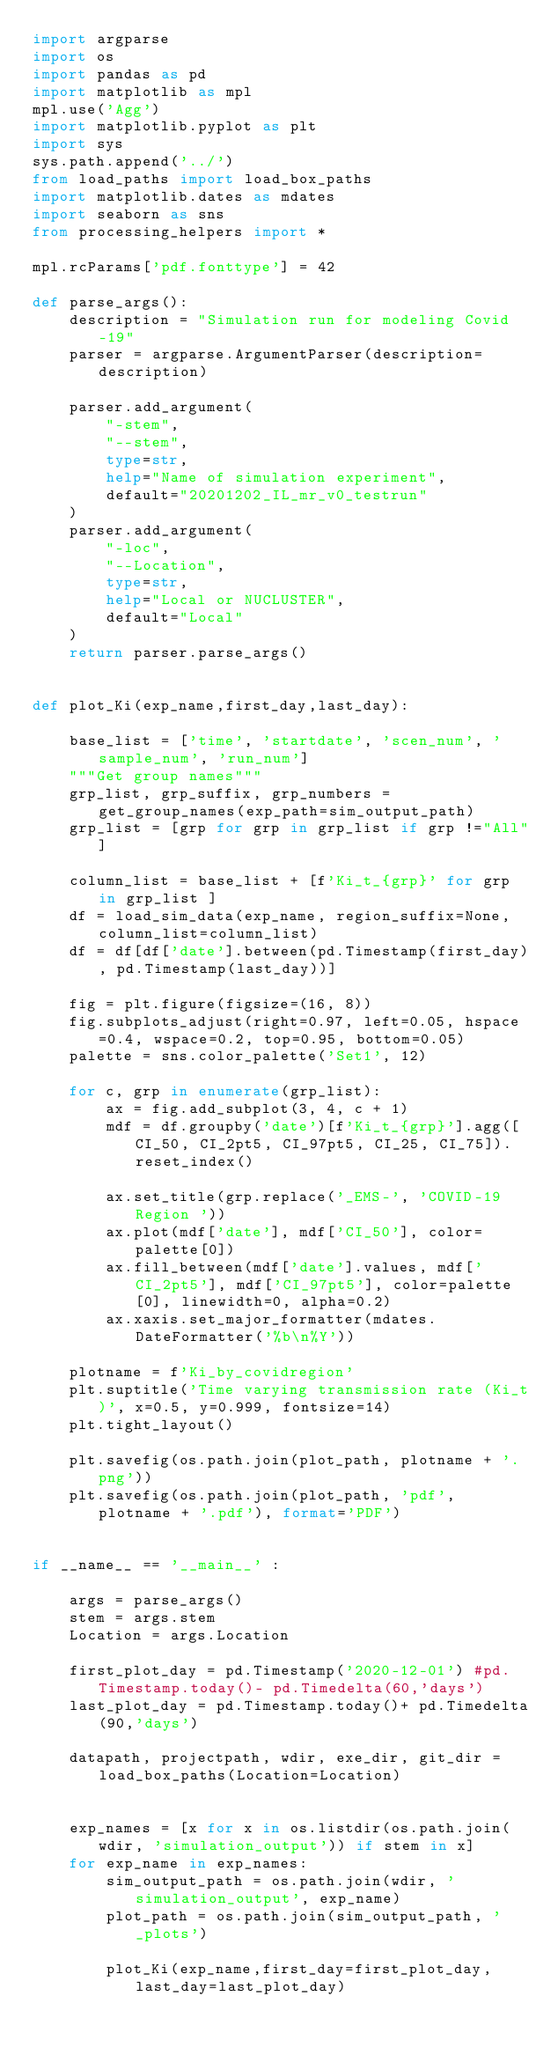Convert code to text. <code><loc_0><loc_0><loc_500><loc_500><_Python_>import argparse
import os
import pandas as pd
import matplotlib as mpl
mpl.use('Agg')
import matplotlib.pyplot as plt
import sys
sys.path.append('../')
from load_paths import load_box_paths
import matplotlib.dates as mdates
import seaborn as sns
from processing_helpers import *

mpl.rcParams['pdf.fonttype'] = 42

def parse_args():
    description = "Simulation run for modeling Covid-19"
    parser = argparse.ArgumentParser(description=description)

    parser.add_argument(
        "-stem",
        "--stem",
        type=str,
        help="Name of simulation experiment",
        default="20201202_IL_mr_v0_testrun"
    )
    parser.add_argument(
        "-loc",
        "--Location",
        type=str,
        help="Local or NUCLUSTER",
        default="Local"
    )
    return parser.parse_args()


def plot_Ki(exp_name,first_day,last_day):

    base_list = ['time', 'startdate', 'scen_num', 'sample_num', 'run_num']
    """Get group names"""
    grp_list, grp_suffix, grp_numbers = get_group_names(exp_path=sim_output_path)
    grp_list = [grp for grp in grp_list if grp !="All"]

    column_list = base_list + [f'Ki_t_{grp}' for grp in grp_list ]
    df = load_sim_data(exp_name, region_suffix=None, column_list=column_list)
    df = df[df['date'].between(pd.Timestamp(first_day), pd.Timestamp(last_day))]

    fig = plt.figure(figsize=(16, 8))
    fig.subplots_adjust(right=0.97, left=0.05, hspace=0.4, wspace=0.2, top=0.95, bottom=0.05)
    palette = sns.color_palette('Set1', 12)

    for c, grp in enumerate(grp_list):
        ax = fig.add_subplot(3, 4, c + 1)
        mdf = df.groupby('date')[f'Ki_t_{grp}'].agg([CI_50, CI_2pt5, CI_97pt5, CI_25, CI_75]).reset_index()

        ax.set_title(grp.replace('_EMS-', 'COVID-19 Region '))
        ax.plot(mdf['date'], mdf['CI_50'], color=palette[0])
        ax.fill_between(mdf['date'].values, mdf['CI_2pt5'], mdf['CI_97pt5'], color=palette[0], linewidth=0, alpha=0.2)
        ax.xaxis.set_major_formatter(mdates.DateFormatter('%b\n%Y'))

    plotname = f'Ki_by_covidregion'
    plt.suptitle('Time varying transmission rate (Ki_t)', x=0.5, y=0.999, fontsize=14)
    plt.tight_layout()

    plt.savefig(os.path.join(plot_path, plotname + '.png'))
    plt.savefig(os.path.join(plot_path, 'pdf', plotname + '.pdf'), format='PDF')


if __name__ == '__main__' :

    args = parse_args()
    stem = args.stem
    Location = args.Location

    first_plot_day = pd.Timestamp('2020-12-01') #pd.Timestamp.today()- pd.Timedelta(60,'days')
    last_plot_day = pd.Timestamp.today()+ pd.Timedelta(90,'days')

    datapath, projectpath, wdir, exe_dir, git_dir = load_box_paths(Location=Location)


    exp_names = [x for x in os.listdir(os.path.join(wdir, 'simulation_output')) if stem in x]
    for exp_name in exp_names:
        sim_output_path = os.path.join(wdir, 'simulation_output', exp_name)
        plot_path = os.path.join(sim_output_path, '_plots')

        plot_Ki(exp_name,first_day=first_plot_day, last_day=last_plot_day)
</code> 